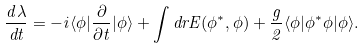Convert formula to latex. <formula><loc_0><loc_0><loc_500><loc_500>\frac { d \lambda } { d t } = - i \langle \phi | \frac { \partial } { \partial t } | \phi \rangle + \int d r E ( \phi ^ { \ast } , \phi ) + \frac { g } { 2 } \langle \phi | \phi ^ { \ast } \phi | \phi \rangle .</formula> 